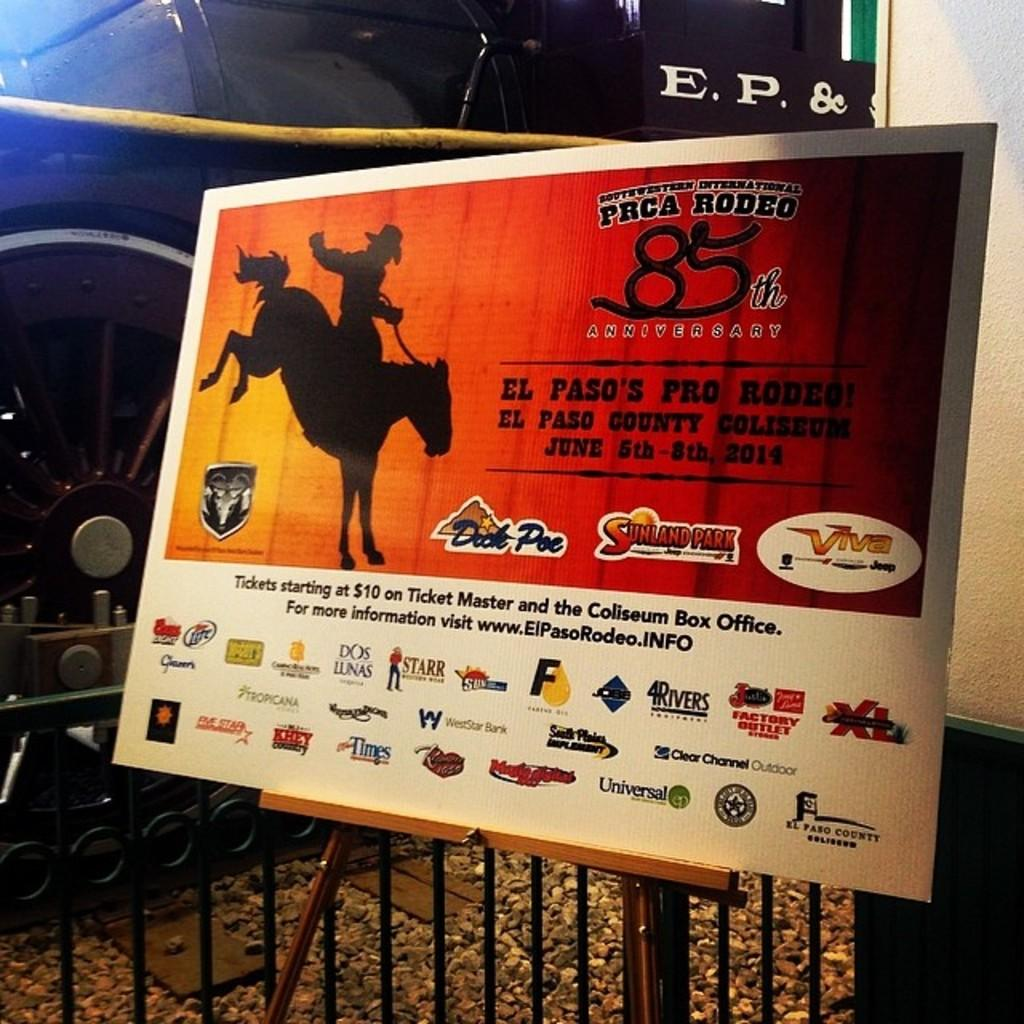<image>
Write a terse but informative summary of the picture. A poster celebrating 85th anniversary of PRCA RODEO. 